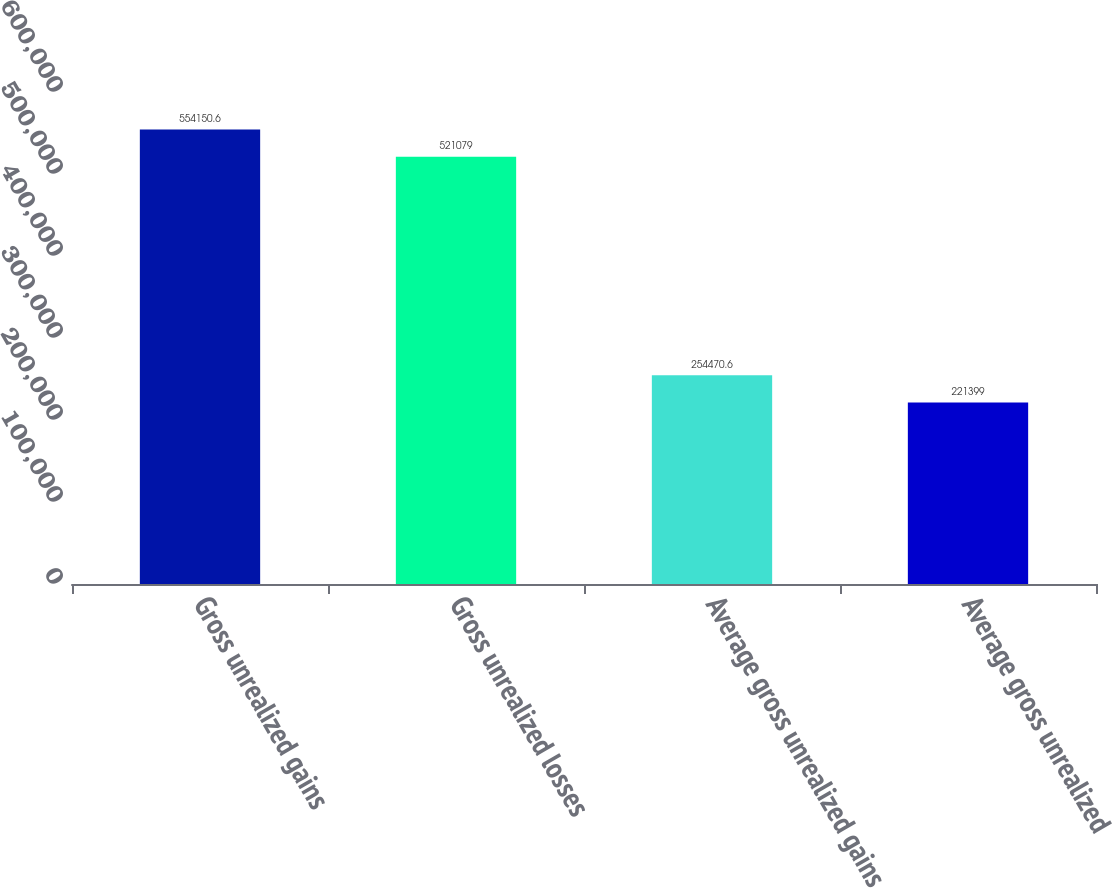<chart> <loc_0><loc_0><loc_500><loc_500><bar_chart><fcel>Gross unrealized gains<fcel>Gross unrealized losses<fcel>Average gross unrealized gains<fcel>Average gross unrealized<nl><fcel>554151<fcel>521079<fcel>254471<fcel>221399<nl></chart> 